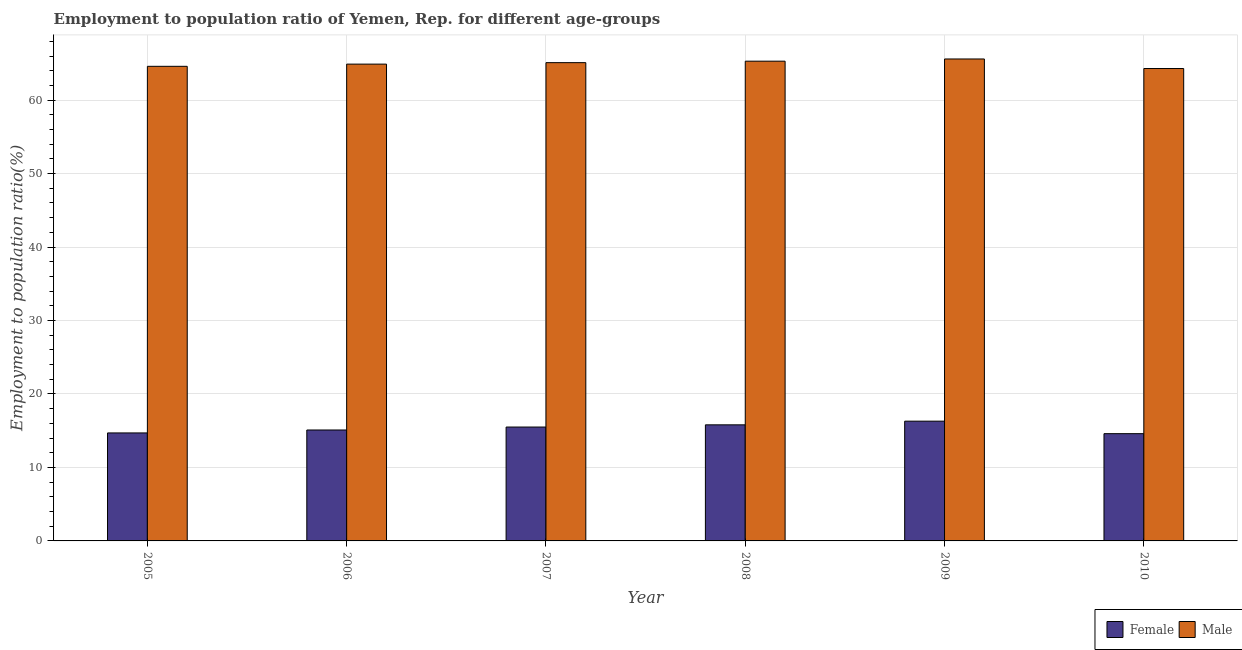How many different coloured bars are there?
Make the answer very short. 2. How many bars are there on the 5th tick from the left?
Offer a very short reply. 2. What is the label of the 4th group of bars from the left?
Give a very brief answer. 2008. What is the employment to population ratio(male) in 2006?
Ensure brevity in your answer.  64.9. Across all years, what is the maximum employment to population ratio(female)?
Your answer should be compact. 16.3. Across all years, what is the minimum employment to population ratio(male)?
Offer a terse response. 64.3. In which year was the employment to population ratio(male) maximum?
Your answer should be compact. 2009. In which year was the employment to population ratio(male) minimum?
Your answer should be compact. 2010. What is the total employment to population ratio(female) in the graph?
Provide a succinct answer. 92. What is the difference between the employment to population ratio(male) in 2005 and that in 2006?
Give a very brief answer. -0.3. What is the difference between the employment to population ratio(male) in 2010 and the employment to population ratio(female) in 2006?
Your answer should be very brief. -0.6. What is the average employment to population ratio(male) per year?
Ensure brevity in your answer.  64.97. What is the ratio of the employment to population ratio(male) in 2007 to that in 2008?
Your response must be concise. 1. What is the difference between the highest and the second highest employment to population ratio(female)?
Your response must be concise. 0.5. What is the difference between the highest and the lowest employment to population ratio(male)?
Offer a very short reply. 1.3. Is the sum of the employment to population ratio(female) in 2006 and 2008 greater than the maximum employment to population ratio(male) across all years?
Keep it short and to the point. Yes. What does the 2nd bar from the left in 2006 represents?
Keep it short and to the point. Male. How many bars are there?
Your response must be concise. 12. What is the difference between two consecutive major ticks on the Y-axis?
Give a very brief answer. 10. Does the graph contain any zero values?
Your answer should be compact. No. Where does the legend appear in the graph?
Your response must be concise. Bottom right. What is the title of the graph?
Ensure brevity in your answer.  Employment to population ratio of Yemen, Rep. for different age-groups. Does "Time to import" appear as one of the legend labels in the graph?
Your answer should be compact. No. What is the label or title of the X-axis?
Keep it short and to the point. Year. What is the Employment to population ratio(%) in Female in 2005?
Your answer should be very brief. 14.7. What is the Employment to population ratio(%) of Male in 2005?
Keep it short and to the point. 64.6. What is the Employment to population ratio(%) of Female in 2006?
Ensure brevity in your answer.  15.1. What is the Employment to population ratio(%) in Male in 2006?
Provide a short and direct response. 64.9. What is the Employment to population ratio(%) of Male in 2007?
Provide a succinct answer. 65.1. What is the Employment to population ratio(%) of Female in 2008?
Provide a succinct answer. 15.8. What is the Employment to population ratio(%) in Male in 2008?
Make the answer very short. 65.3. What is the Employment to population ratio(%) in Female in 2009?
Offer a very short reply. 16.3. What is the Employment to population ratio(%) in Male in 2009?
Your response must be concise. 65.6. What is the Employment to population ratio(%) of Female in 2010?
Offer a terse response. 14.6. What is the Employment to population ratio(%) of Male in 2010?
Make the answer very short. 64.3. Across all years, what is the maximum Employment to population ratio(%) in Female?
Provide a short and direct response. 16.3. Across all years, what is the maximum Employment to population ratio(%) of Male?
Your response must be concise. 65.6. Across all years, what is the minimum Employment to population ratio(%) of Female?
Keep it short and to the point. 14.6. Across all years, what is the minimum Employment to population ratio(%) of Male?
Your answer should be compact. 64.3. What is the total Employment to population ratio(%) of Female in the graph?
Your answer should be compact. 92. What is the total Employment to population ratio(%) of Male in the graph?
Provide a succinct answer. 389.8. What is the difference between the Employment to population ratio(%) in Male in 2005 and that in 2006?
Your answer should be compact. -0.3. What is the difference between the Employment to population ratio(%) in Female in 2005 and that in 2007?
Your answer should be very brief. -0.8. What is the difference between the Employment to population ratio(%) in Male in 2005 and that in 2008?
Provide a short and direct response. -0.7. What is the difference between the Employment to population ratio(%) of Female in 2005 and that in 2009?
Make the answer very short. -1.6. What is the difference between the Employment to population ratio(%) in Male in 2005 and that in 2009?
Provide a short and direct response. -1. What is the difference between the Employment to population ratio(%) of Female in 2005 and that in 2010?
Give a very brief answer. 0.1. What is the difference between the Employment to population ratio(%) of Female in 2006 and that in 2007?
Your answer should be very brief. -0.4. What is the difference between the Employment to population ratio(%) in Male in 2006 and that in 2008?
Keep it short and to the point. -0.4. What is the difference between the Employment to population ratio(%) of Male in 2006 and that in 2009?
Your response must be concise. -0.7. What is the difference between the Employment to population ratio(%) in Male in 2007 and that in 2008?
Provide a short and direct response. -0.2. What is the difference between the Employment to population ratio(%) in Male in 2007 and that in 2009?
Ensure brevity in your answer.  -0.5. What is the difference between the Employment to population ratio(%) of Male in 2007 and that in 2010?
Ensure brevity in your answer.  0.8. What is the difference between the Employment to population ratio(%) in Female in 2008 and that in 2009?
Your answer should be compact. -0.5. What is the difference between the Employment to population ratio(%) in Male in 2008 and that in 2010?
Provide a succinct answer. 1. What is the difference between the Employment to population ratio(%) in Female in 2009 and that in 2010?
Offer a very short reply. 1.7. What is the difference between the Employment to population ratio(%) in Female in 2005 and the Employment to population ratio(%) in Male in 2006?
Make the answer very short. -50.2. What is the difference between the Employment to population ratio(%) of Female in 2005 and the Employment to population ratio(%) of Male in 2007?
Your response must be concise. -50.4. What is the difference between the Employment to population ratio(%) of Female in 2005 and the Employment to population ratio(%) of Male in 2008?
Your response must be concise. -50.6. What is the difference between the Employment to population ratio(%) in Female in 2005 and the Employment to population ratio(%) in Male in 2009?
Your answer should be very brief. -50.9. What is the difference between the Employment to population ratio(%) in Female in 2005 and the Employment to population ratio(%) in Male in 2010?
Give a very brief answer. -49.6. What is the difference between the Employment to population ratio(%) of Female in 2006 and the Employment to population ratio(%) of Male in 2007?
Offer a terse response. -50. What is the difference between the Employment to population ratio(%) in Female in 2006 and the Employment to population ratio(%) in Male in 2008?
Offer a terse response. -50.2. What is the difference between the Employment to population ratio(%) in Female in 2006 and the Employment to population ratio(%) in Male in 2009?
Give a very brief answer. -50.5. What is the difference between the Employment to population ratio(%) in Female in 2006 and the Employment to population ratio(%) in Male in 2010?
Give a very brief answer. -49.2. What is the difference between the Employment to population ratio(%) of Female in 2007 and the Employment to population ratio(%) of Male in 2008?
Give a very brief answer. -49.8. What is the difference between the Employment to population ratio(%) in Female in 2007 and the Employment to population ratio(%) in Male in 2009?
Your answer should be very brief. -50.1. What is the difference between the Employment to population ratio(%) of Female in 2007 and the Employment to population ratio(%) of Male in 2010?
Your answer should be compact. -48.8. What is the difference between the Employment to population ratio(%) in Female in 2008 and the Employment to population ratio(%) in Male in 2009?
Give a very brief answer. -49.8. What is the difference between the Employment to population ratio(%) in Female in 2008 and the Employment to population ratio(%) in Male in 2010?
Your answer should be compact. -48.5. What is the difference between the Employment to population ratio(%) of Female in 2009 and the Employment to population ratio(%) of Male in 2010?
Your response must be concise. -48. What is the average Employment to population ratio(%) in Female per year?
Offer a very short reply. 15.33. What is the average Employment to population ratio(%) in Male per year?
Provide a succinct answer. 64.97. In the year 2005, what is the difference between the Employment to population ratio(%) of Female and Employment to population ratio(%) of Male?
Give a very brief answer. -49.9. In the year 2006, what is the difference between the Employment to population ratio(%) in Female and Employment to population ratio(%) in Male?
Make the answer very short. -49.8. In the year 2007, what is the difference between the Employment to population ratio(%) in Female and Employment to population ratio(%) in Male?
Offer a very short reply. -49.6. In the year 2008, what is the difference between the Employment to population ratio(%) of Female and Employment to population ratio(%) of Male?
Ensure brevity in your answer.  -49.5. In the year 2009, what is the difference between the Employment to population ratio(%) of Female and Employment to population ratio(%) of Male?
Provide a short and direct response. -49.3. In the year 2010, what is the difference between the Employment to population ratio(%) of Female and Employment to population ratio(%) of Male?
Your answer should be compact. -49.7. What is the ratio of the Employment to population ratio(%) in Female in 2005 to that in 2006?
Give a very brief answer. 0.97. What is the ratio of the Employment to population ratio(%) of Female in 2005 to that in 2007?
Provide a short and direct response. 0.95. What is the ratio of the Employment to population ratio(%) of Male in 2005 to that in 2007?
Offer a terse response. 0.99. What is the ratio of the Employment to population ratio(%) in Female in 2005 to that in 2008?
Your answer should be very brief. 0.93. What is the ratio of the Employment to population ratio(%) of Male in 2005 to that in 2008?
Ensure brevity in your answer.  0.99. What is the ratio of the Employment to population ratio(%) of Female in 2005 to that in 2009?
Your response must be concise. 0.9. What is the ratio of the Employment to population ratio(%) of Male in 2005 to that in 2009?
Provide a short and direct response. 0.98. What is the ratio of the Employment to population ratio(%) of Female in 2005 to that in 2010?
Provide a succinct answer. 1.01. What is the ratio of the Employment to population ratio(%) in Female in 2006 to that in 2007?
Offer a very short reply. 0.97. What is the ratio of the Employment to population ratio(%) in Male in 2006 to that in 2007?
Your answer should be compact. 1. What is the ratio of the Employment to population ratio(%) of Female in 2006 to that in 2008?
Keep it short and to the point. 0.96. What is the ratio of the Employment to population ratio(%) of Female in 2006 to that in 2009?
Offer a terse response. 0.93. What is the ratio of the Employment to population ratio(%) of Male in 2006 to that in 2009?
Offer a terse response. 0.99. What is the ratio of the Employment to population ratio(%) of Female in 2006 to that in 2010?
Provide a short and direct response. 1.03. What is the ratio of the Employment to population ratio(%) in Male in 2006 to that in 2010?
Your answer should be very brief. 1.01. What is the ratio of the Employment to population ratio(%) of Male in 2007 to that in 2008?
Keep it short and to the point. 1. What is the ratio of the Employment to population ratio(%) of Female in 2007 to that in 2009?
Your answer should be compact. 0.95. What is the ratio of the Employment to population ratio(%) in Female in 2007 to that in 2010?
Provide a short and direct response. 1.06. What is the ratio of the Employment to population ratio(%) in Male in 2007 to that in 2010?
Make the answer very short. 1.01. What is the ratio of the Employment to population ratio(%) in Female in 2008 to that in 2009?
Provide a short and direct response. 0.97. What is the ratio of the Employment to population ratio(%) in Female in 2008 to that in 2010?
Your answer should be compact. 1.08. What is the ratio of the Employment to population ratio(%) in Male in 2008 to that in 2010?
Your response must be concise. 1.02. What is the ratio of the Employment to population ratio(%) in Female in 2009 to that in 2010?
Offer a very short reply. 1.12. What is the ratio of the Employment to population ratio(%) in Male in 2009 to that in 2010?
Offer a very short reply. 1.02. What is the difference between the highest and the second highest Employment to population ratio(%) of Male?
Provide a short and direct response. 0.3. What is the difference between the highest and the lowest Employment to population ratio(%) in Female?
Make the answer very short. 1.7. 